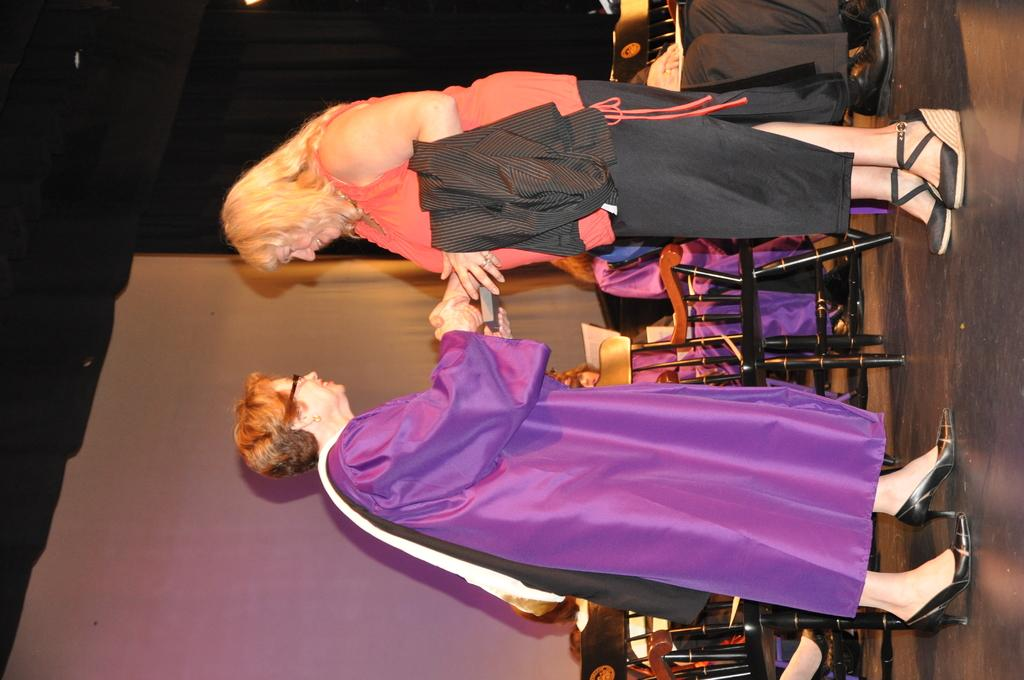How many women are in the image? There are two women in the image. What are the women doing in the image? The women are standing and smiling. Can you describe the people in the background of the image? There are people sitting in the background of the image. What is the color of the background in the image? The background of the image is dark. What type of quince is being used as a decoration in the image? There is no quince present in the image. How are the women transporting themselves in the image? The women are not shown to be transporting themselves in the image; they are standing still. 